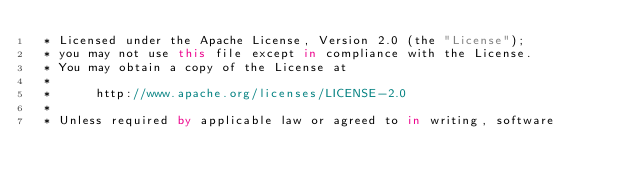Convert code to text. <code><loc_0><loc_0><loc_500><loc_500><_Kotlin_> * Licensed under the Apache License, Version 2.0 (the "License");
 * you may not use this file except in compliance with the License.
 * You may obtain a copy of the License at
 *
 *      http://www.apache.org/licenses/LICENSE-2.0
 *
 * Unless required by applicable law or agreed to in writing, software</code> 